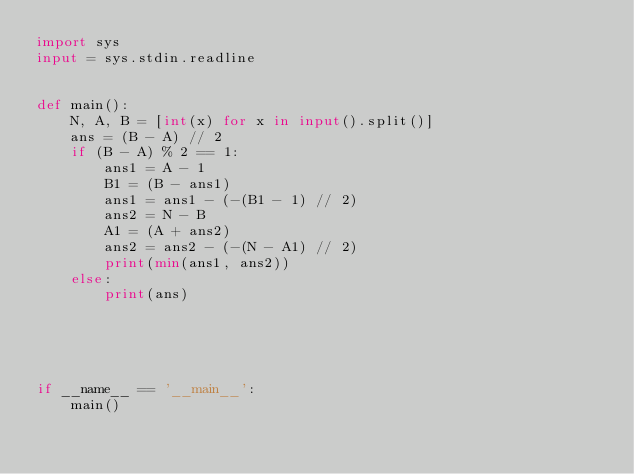<code> <loc_0><loc_0><loc_500><loc_500><_Python_>import sys
input = sys.stdin.readline


def main():
    N, A, B = [int(x) for x in input().split()]
    ans = (B - A) // 2
    if (B - A) % 2 == 1:
        ans1 = A - 1
        B1 = (B - ans1)
        ans1 = ans1 - (-(B1 - 1) // 2)
        ans2 = N - B
        A1 = (A + ans2)
        ans2 = ans2 - (-(N - A1) // 2)
        print(min(ans1, ans2))
    else:
        print(ans)





if __name__ == '__main__':
    main()

</code> 